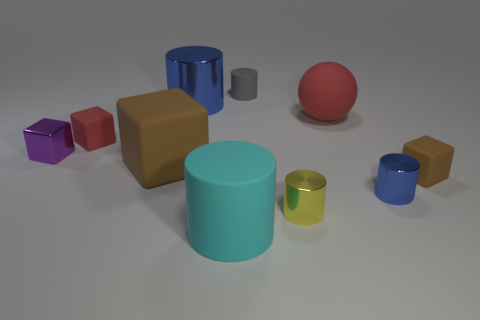Does the blue thing in front of the red matte ball have the same material as the small red thing?
Keep it short and to the point. No. Is the shape of the gray object the same as the small blue metal object?
Make the answer very short. Yes. What is the shape of the brown thing that is left of the brown matte thing that is on the right side of the large cylinder in front of the small purple thing?
Make the answer very short. Cube. Is the shape of the metallic object on the right side of the tiny yellow cylinder the same as the red thing to the right of the tiny red block?
Offer a very short reply. No. Is there a small brown cube made of the same material as the large blue object?
Offer a terse response. No. What is the color of the tiny object that is behind the block behind the tiny metallic thing that is to the left of the large cyan cylinder?
Make the answer very short. Gray. Is the material of the red object that is to the left of the small gray rubber thing the same as the cube that is on the right side of the tiny blue cylinder?
Your answer should be compact. Yes. What is the shape of the blue metal object behind the tiny brown thing?
Offer a terse response. Cylinder. What number of things are either purple cylinders or blue metal cylinders that are left of the big cyan object?
Provide a short and direct response. 1. Is the large cyan thing made of the same material as the small gray thing?
Make the answer very short. Yes. 